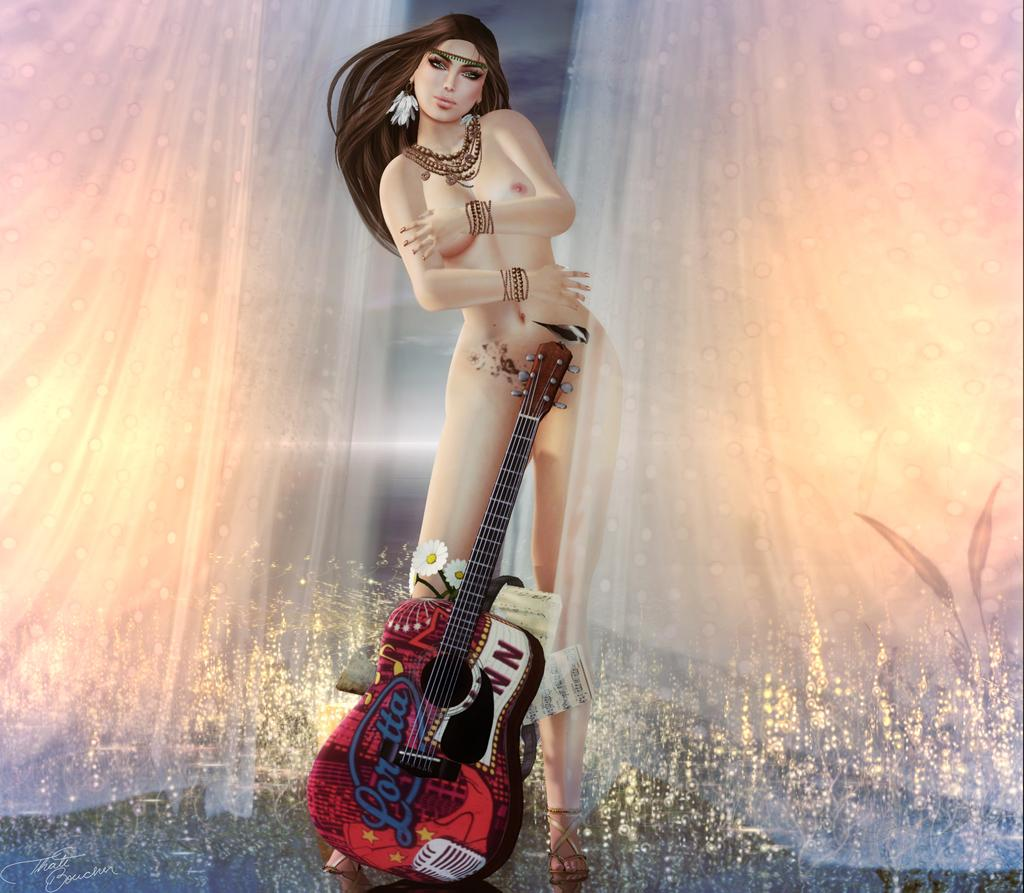What is the main subject of the image? There is a woman standing in the image. What is the woman doing in the image? The woman is standing in front of a musical instrument. What can be seen in the background of the image? There are plants visible in the image. What else is present in the image besides the woman and the musical instrument? There are clothes present in the image. What type of food is the woman preparing in the image? There is no food visible in the image, and the woman is not preparing any food. 